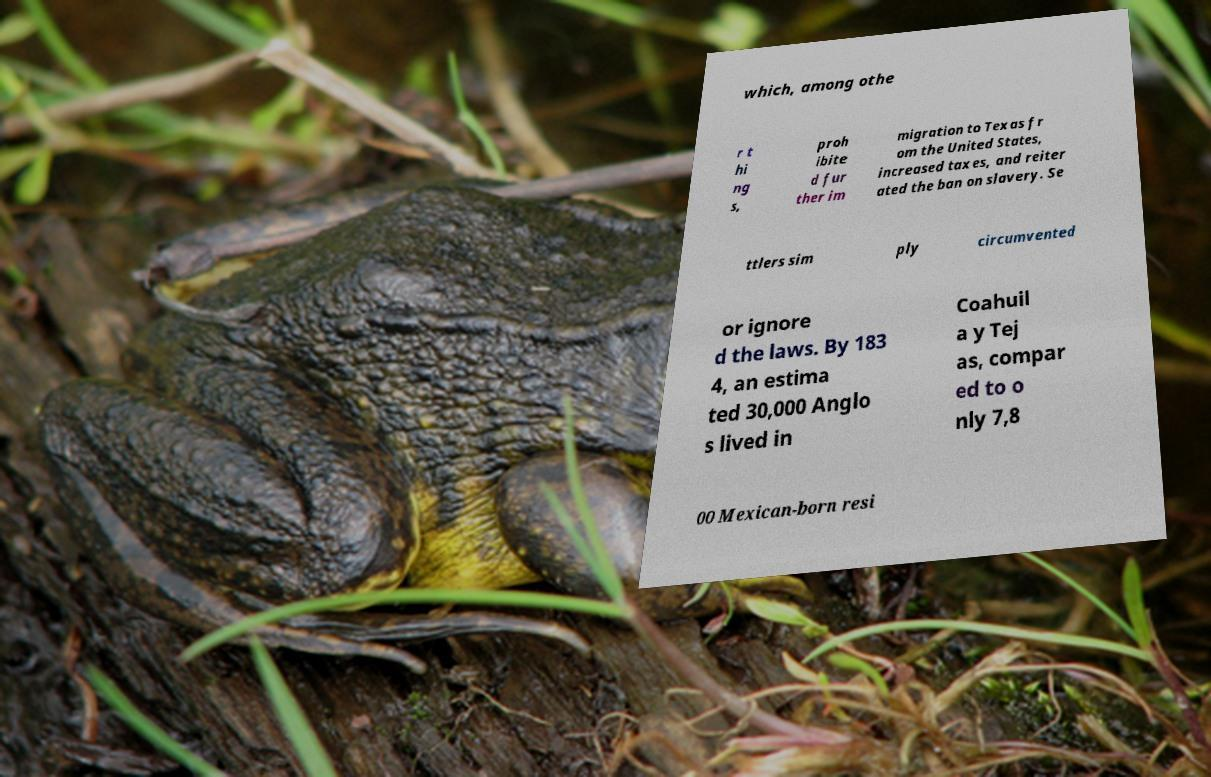For documentation purposes, I need the text within this image transcribed. Could you provide that? which, among othe r t hi ng s, proh ibite d fur ther im migration to Texas fr om the United States, increased taxes, and reiter ated the ban on slavery. Se ttlers sim ply circumvented or ignore d the laws. By 183 4, an estima ted 30,000 Anglo s lived in Coahuil a y Tej as, compar ed to o nly 7,8 00 Mexican-born resi 